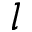Convert formula to latex. <formula><loc_0><loc_0><loc_500><loc_500>l</formula> 